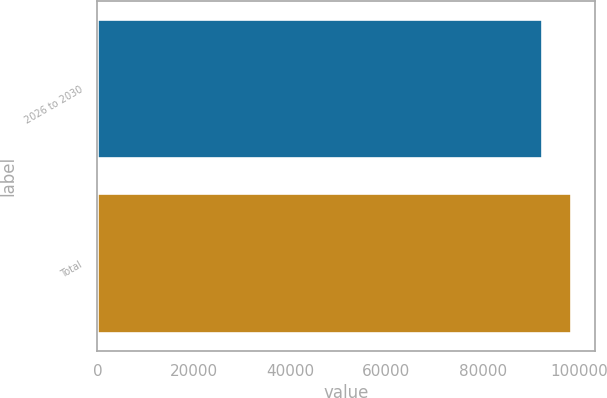Convert chart to OTSL. <chart><loc_0><loc_0><loc_500><loc_500><bar_chart><fcel>2026 to 2030<fcel>Total<nl><fcel>92412<fcel>98424<nl></chart> 